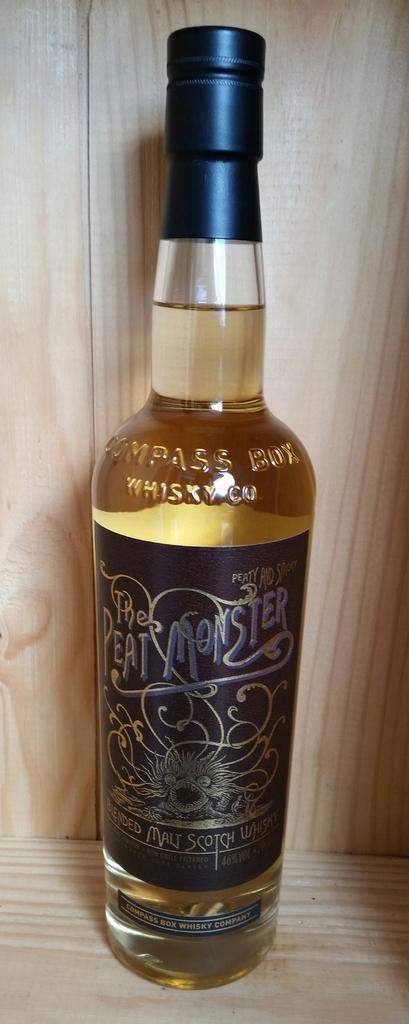Is peat monster a brand of scotch?
Your response must be concise. Yes. Which company makes this whiskey?
Provide a succinct answer. The peat monster. 